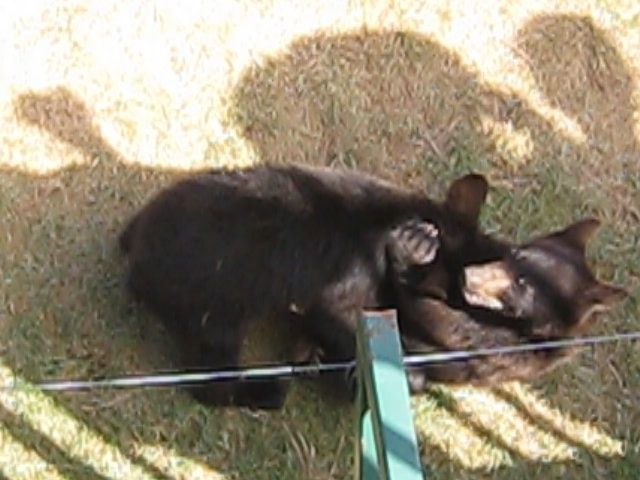Describe the objects in this image and their specific colors. I can see a bear in white, black, and gray tones in this image. 